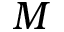Convert formula to latex. <formula><loc_0><loc_0><loc_500><loc_500>M</formula> 